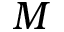Convert formula to latex. <formula><loc_0><loc_0><loc_500><loc_500>M</formula> 